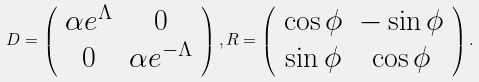<formula> <loc_0><loc_0><loc_500><loc_500>D = \left ( \begin{array} { c c } \alpha e ^ { \Lambda } & 0 \\ 0 & \alpha e ^ { - \Lambda } \end{array} \right ) , R = \left ( \begin{array} { c c } \cos \phi & - \sin \phi \\ \sin \phi & \cos \phi \end{array} \right ) .</formula> 